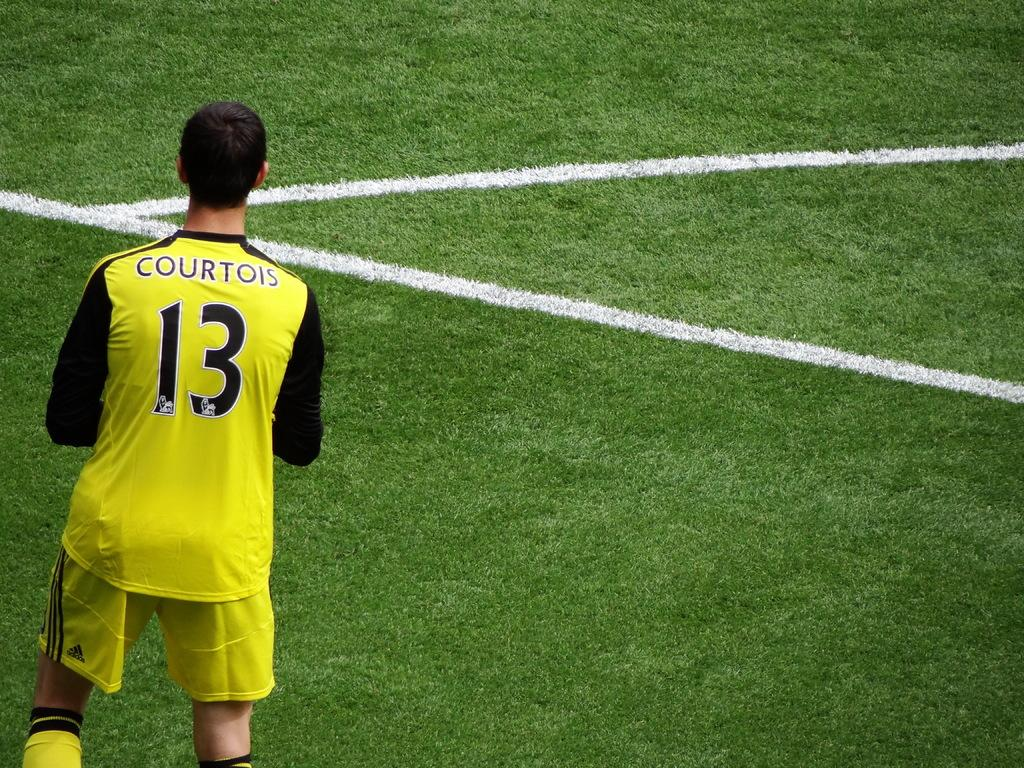Provide a one-sentence caption for the provided image. a person with the number 13 on their soccer jersey. 